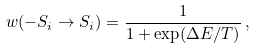<formula> <loc_0><loc_0><loc_500><loc_500>w ( - S _ { i } \rightarrow S _ { i } ) = \frac { 1 } { 1 + \exp ( \Delta E / T ) } \, ,</formula> 